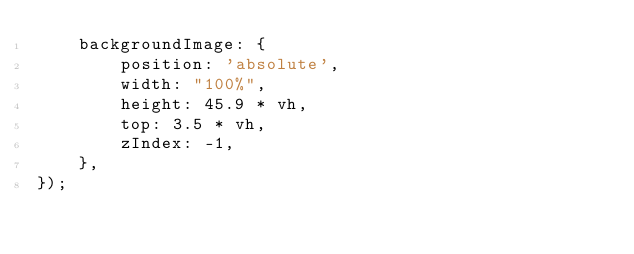Convert code to text. <code><loc_0><loc_0><loc_500><loc_500><_JavaScript_>    backgroundImage: {
        position: 'absolute',
        width: "100%",
        height: 45.9 * vh,
        top: 3.5 * vh,
        zIndex: -1,
    },
});
</code> 